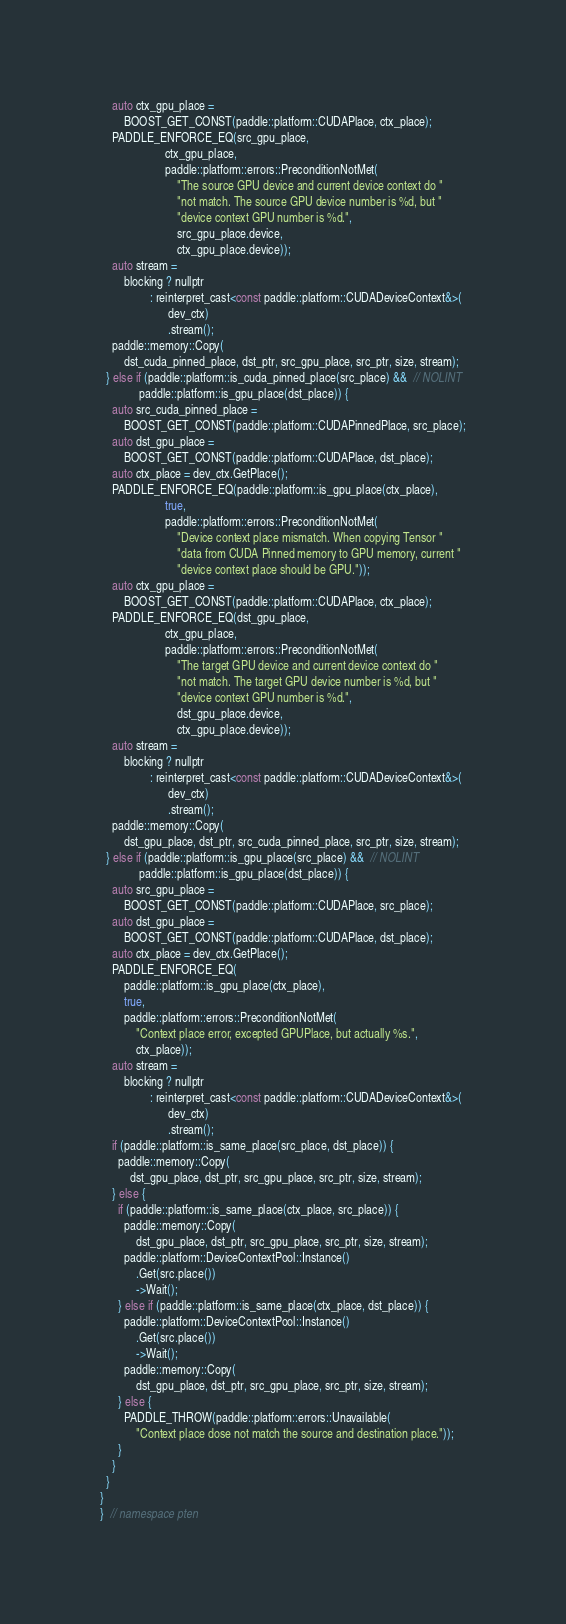Convert code to text. <code><loc_0><loc_0><loc_500><loc_500><_Cuda_>    auto ctx_gpu_place =
        BOOST_GET_CONST(paddle::platform::CUDAPlace, ctx_place);
    PADDLE_ENFORCE_EQ(src_gpu_place,
                      ctx_gpu_place,
                      paddle::platform::errors::PreconditionNotMet(
                          "The source GPU device and current device context do "
                          "not match. The source GPU device number is %d, but "
                          "device context GPU number is %d.",
                          src_gpu_place.device,
                          ctx_gpu_place.device));
    auto stream =
        blocking ? nullptr
                 : reinterpret_cast<const paddle::platform::CUDADeviceContext&>(
                       dev_ctx)
                       .stream();
    paddle::memory::Copy(
        dst_cuda_pinned_place, dst_ptr, src_gpu_place, src_ptr, size, stream);
  } else if (paddle::platform::is_cuda_pinned_place(src_place) &&  // NOLINT
             paddle::platform::is_gpu_place(dst_place)) {
    auto src_cuda_pinned_place =
        BOOST_GET_CONST(paddle::platform::CUDAPinnedPlace, src_place);
    auto dst_gpu_place =
        BOOST_GET_CONST(paddle::platform::CUDAPlace, dst_place);
    auto ctx_place = dev_ctx.GetPlace();
    PADDLE_ENFORCE_EQ(paddle::platform::is_gpu_place(ctx_place),
                      true,
                      paddle::platform::errors::PreconditionNotMet(
                          "Device context place mismatch. When copying Tensor "
                          "data from CUDA Pinned memory to GPU memory, current "
                          "device context place should be GPU."));
    auto ctx_gpu_place =
        BOOST_GET_CONST(paddle::platform::CUDAPlace, ctx_place);
    PADDLE_ENFORCE_EQ(dst_gpu_place,
                      ctx_gpu_place,
                      paddle::platform::errors::PreconditionNotMet(
                          "The target GPU device and current device context do "
                          "not match. The target GPU device number is %d, but "
                          "device context GPU number is %d.",
                          dst_gpu_place.device,
                          ctx_gpu_place.device));
    auto stream =
        blocking ? nullptr
                 : reinterpret_cast<const paddle::platform::CUDADeviceContext&>(
                       dev_ctx)
                       .stream();
    paddle::memory::Copy(
        dst_gpu_place, dst_ptr, src_cuda_pinned_place, src_ptr, size, stream);
  } else if (paddle::platform::is_gpu_place(src_place) &&  // NOLINT
             paddle::platform::is_gpu_place(dst_place)) {
    auto src_gpu_place =
        BOOST_GET_CONST(paddle::platform::CUDAPlace, src_place);
    auto dst_gpu_place =
        BOOST_GET_CONST(paddle::platform::CUDAPlace, dst_place);
    auto ctx_place = dev_ctx.GetPlace();
    PADDLE_ENFORCE_EQ(
        paddle::platform::is_gpu_place(ctx_place),
        true,
        paddle::platform::errors::PreconditionNotMet(
            "Context place error, excepted GPUPlace, but actually %s.",
            ctx_place));
    auto stream =
        blocking ? nullptr
                 : reinterpret_cast<const paddle::platform::CUDADeviceContext&>(
                       dev_ctx)
                       .stream();
    if (paddle::platform::is_same_place(src_place, dst_place)) {
      paddle::memory::Copy(
          dst_gpu_place, dst_ptr, src_gpu_place, src_ptr, size, stream);
    } else {
      if (paddle::platform::is_same_place(ctx_place, src_place)) {
        paddle::memory::Copy(
            dst_gpu_place, dst_ptr, src_gpu_place, src_ptr, size, stream);
        paddle::platform::DeviceContextPool::Instance()
            .Get(src.place())
            ->Wait();
      } else if (paddle::platform::is_same_place(ctx_place, dst_place)) {
        paddle::platform::DeviceContextPool::Instance()
            .Get(src.place())
            ->Wait();
        paddle::memory::Copy(
            dst_gpu_place, dst_ptr, src_gpu_place, src_ptr, size, stream);
      } else {
        PADDLE_THROW(paddle::platform::errors::Unavailable(
            "Context place dose not match the source and destination place."));
      }
    }
  }
}
}  // namespace pten
</code> 